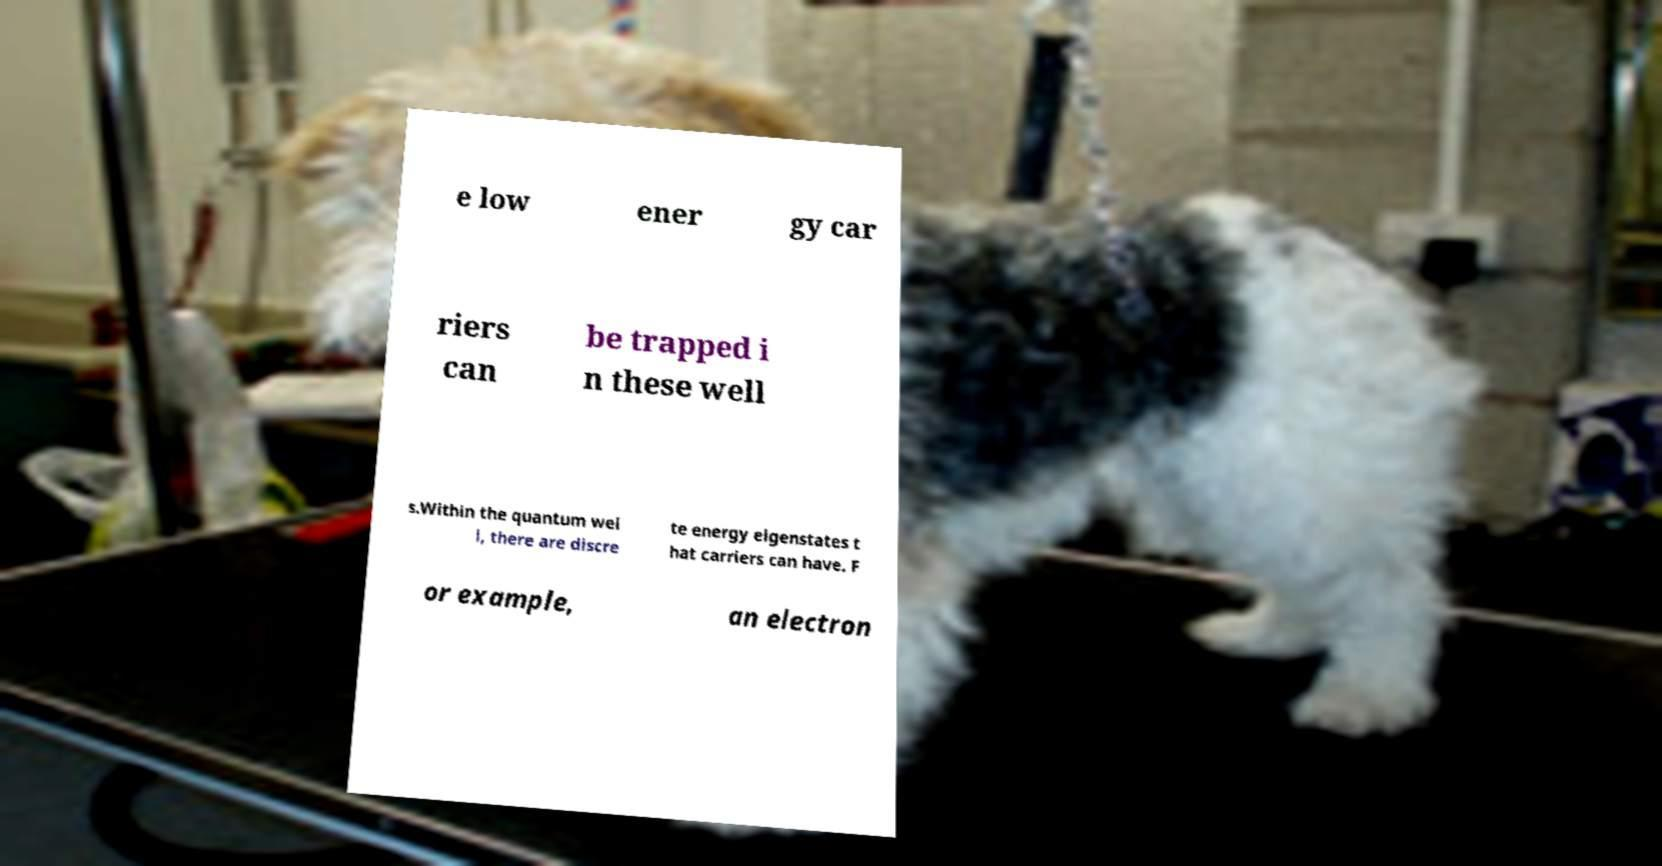For documentation purposes, I need the text within this image transcribed. Could you provide that? e low ener gy car riers can be trapped i n these well s.Within the quantum wel l, there are discre te energy eigenstates t hat carriers can have. F or example, an electron 